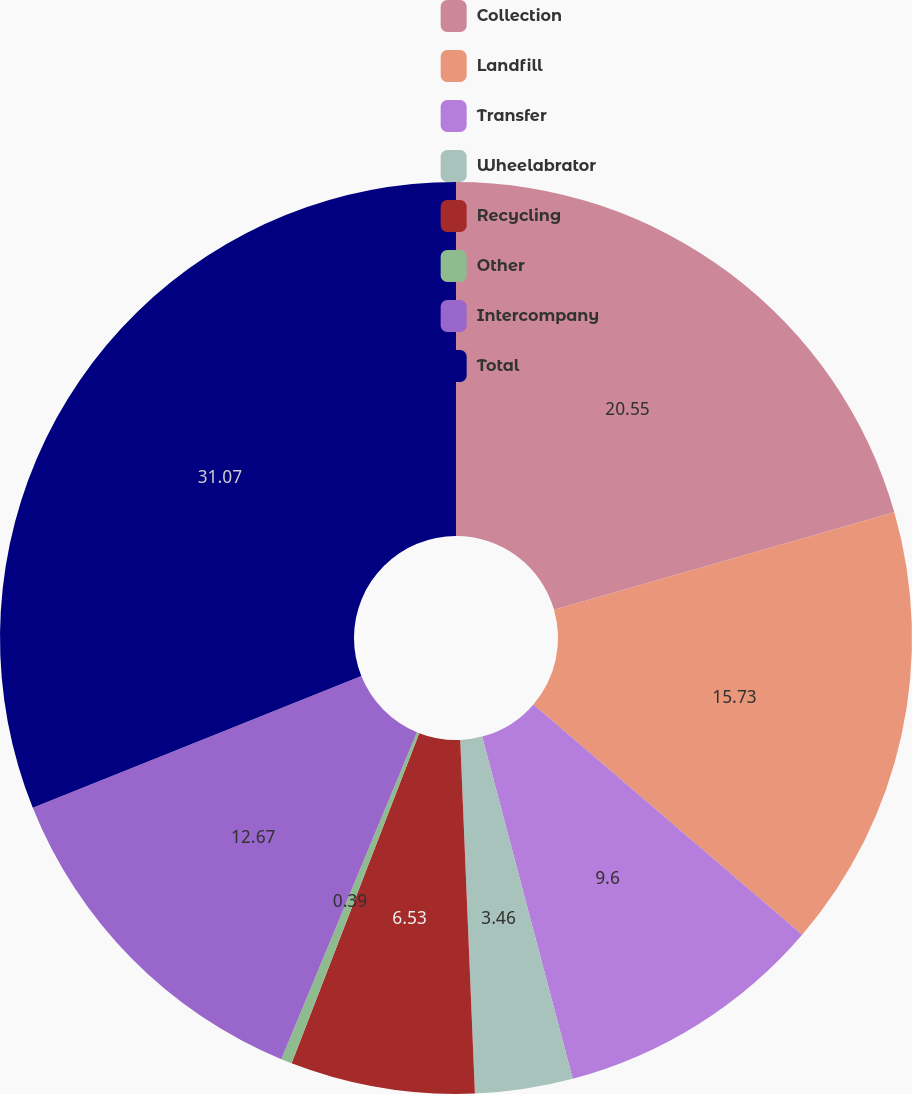Convert chart. <chart><loc_0><loc_0><loc_500><loc_500><pie_chart><fcel>Collection<fcel>Landfill<fcel>Transfer<fcel>Wheelabrator<fcel>Recycling<fcel>Other<fcel>Intercompany<fcel>Total<nl><fcel>20.55%<fcel>15.73%<fcel>9.6%<fcel>3.46%<fcel>6.53%<fcel>0.39%<fcel>12.67%<fcel>31.07%<nl></chart> 